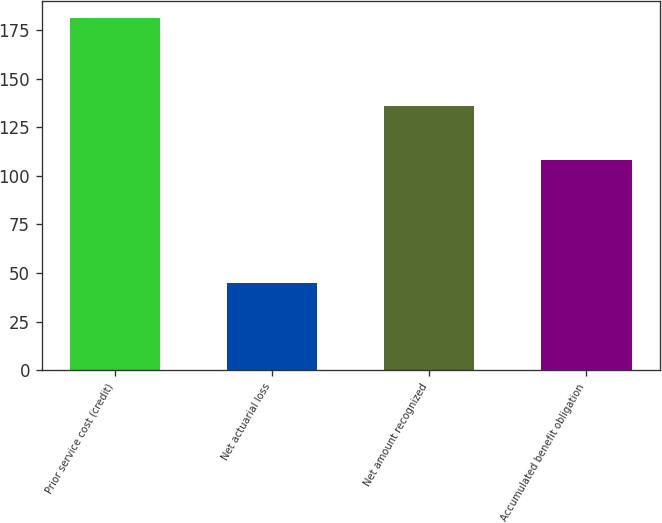Convert chart. <chart><loc_0><loc_0><loc_500><loc_500><bar_chart><fcel>Prior service cost (credit)<fcel>Net actuarial loss<fcel>Net amount recognized<fcel>Accumulated benefit obligation<nl><fcel>181<fcel>45<fcel>136<fcel>108<nl></chart> 